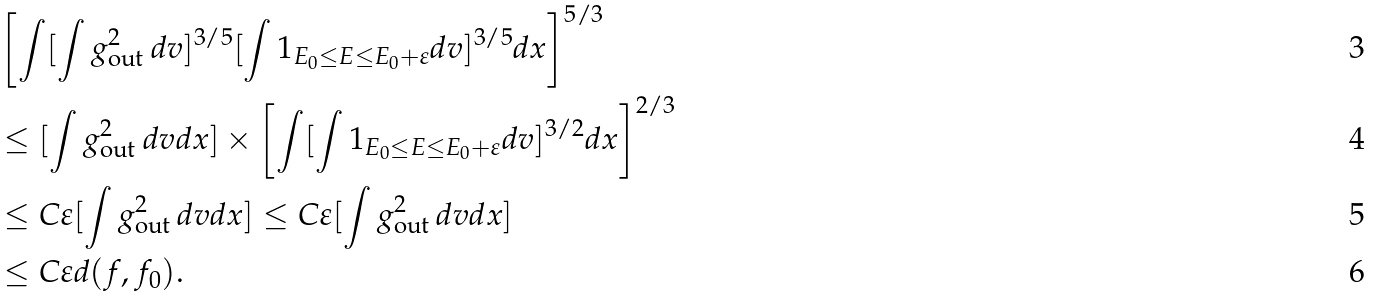Convert formula to latex. <formula><loc_0><loc_0><loc_500><loc_500>& \left [ \int [ \int g _ { \text {out } } ^ { 2 } d v ] ^ { 3 / 5 } [ \int 1 _ { E _ { 0 } \leq E \leq E _ { 0 } + \varepsilon } d v ] ^ { 3 / 5 } d x \right ] ^ { 5 / 3 } \\ & \leq [ \int g _ { \text {out } } ^ { 2 } d v d x ] \times \left [ \int [ \int 1 _ { E _ { 0 } \leq E \leq E _ { 0 } + \varepsilon } d v ] ^ { 3 / 2 } d x \right ] ^ { 2 / 3 } \\ & \leq C \varepsilon [ \int g _ { \text {out } } ^ { 2 } d v d x ] \leq C \varepsilon [ \int g _ { \text {out } } ^ { 2 } d v d x ] \\ & \leq C \varepsilon d ( f , f _ { 0 } ) .</formula> 